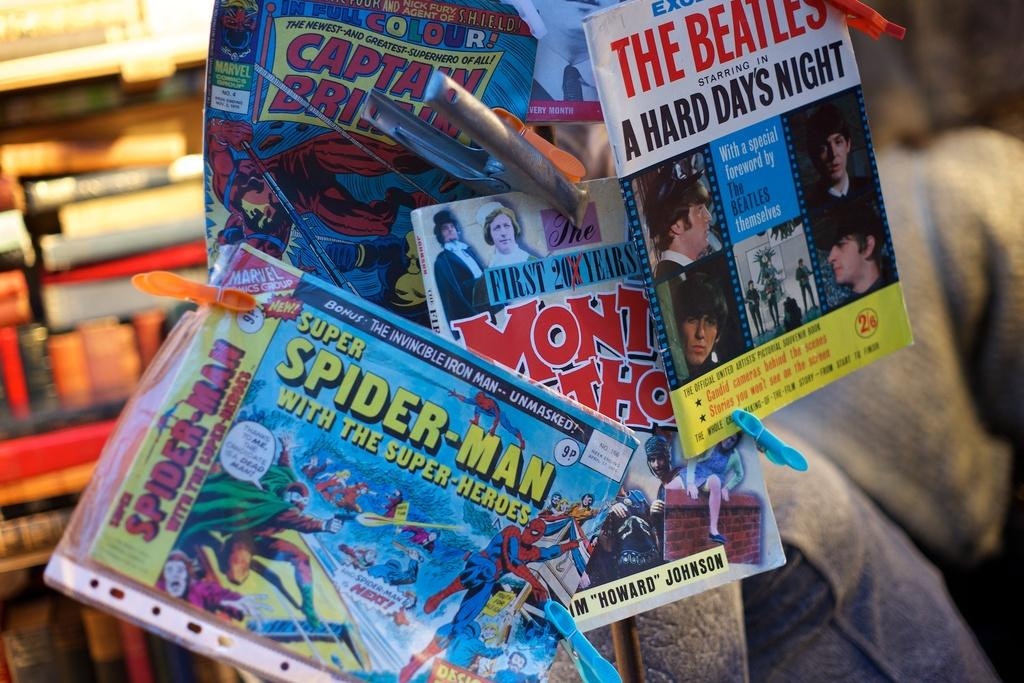<image>
Render a clear and concise summary of the photo. A pile of comic books are clipped together including Super Spider-Man. 